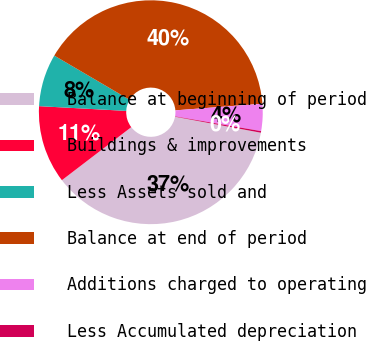Convert chart to OTSL. <chart><loc_0><loc_0><loc_500><loc_500><pie_chart><fcel>Balance at beginning of period<fcel>Buildings & improvements<fcel>Less Assets sold and<fcel>Balance at end of period<fcel>Additions charged to operating<fcel>Less Accumulated depreciation<nl><fcel>36.68%<fcel>11.25%<fcel>7.58%<fcel>40.35%<fcel>3.91%<fcel>0.23%<nl></chart> 